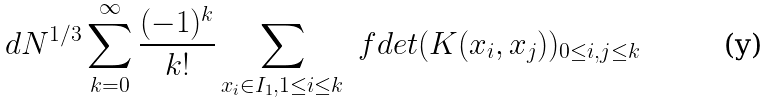<formula> <loc_0><loc_0><loc_500><loc_500>d N ^ { 1 / 3 } \sum _ { k = 0 } ^ { \infty } \frac { ( - 1 ) ^ { k } } { k ! } \sum _ { x _ { i } \in I _ { 1 } , 1 \leq i \leq k } \ f d e t ( K ( x _ { i } , x _ { j } ) ) _ { 0 \leq i , j \leq k }</formula> 